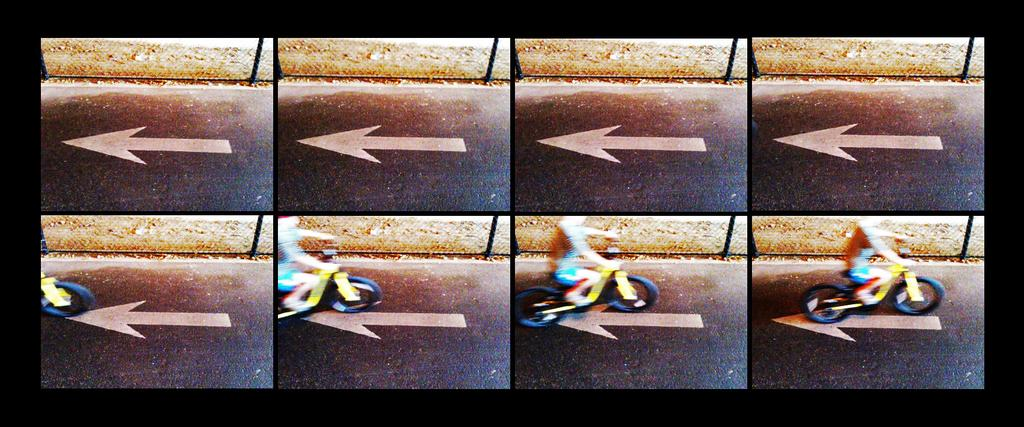What type of artwork is featured in the image? The image contains a collage. What is the person in the image doing? The person is riding a motor vehicle in the image. Where is the motor vehicle located? The motor vehicle is on the road in the image. What can be seen on the road in the image? There is a sign on the road in the image. What type of barrier is present in the image? There is a metal fence in the image. What type of word is being used to promote peace during dinner in the image? There is no reference to a word, peace, or dinner in the image; it features a collage with a person riding a motor vehicle, a sign on the road, and a metal fence. 